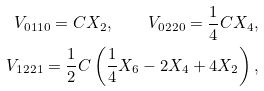Convert formula to latex. <formula><loc_0><loc_0><loc_500><loc_500>V _ { 0 1 1 0 } = C X _ { 2 } , \quad V _ { 0 2 2 0 } = \frac { 1 } { 4 } C X _ { 4 } , \\ V _ { 1 2 2 1 } = \frac { 1 } { 2 } C \left ( \frac { 1 } { 4 } X _ { 6 } - 2 X _ { 4 } + 4 X _ { 2 } \right ) ,</formula> 